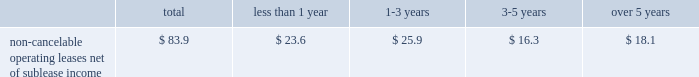Building .
The construction of the building was completed in december 2003 .
Due to lower than expected financing and construction costs , the final lease balance was lowered to $ 103.0 million .
As part of the agreement , we entered into a five-year lease that began upon the completion of the building .
At the end of the lease term , we can purchase the building for the lease balance , remarket or relinquish the building .
If we choose to remarket or are required to do so upon relinquishing the building , we are bound to arrange the sale of the building to an unrelated party and will be required to pay the lessor any shortfall between the net remarketing proceeds and the lease balance , up to the maximum recourse amount of $ 90.8 million ( 201cresidual value guarantee 201d ) .
See note 14 in our notes to consolidated financial statements for further information .
In august 1999 , we entered into a five-year lease agreement for our other two office buildings that currently serve as our corporate headquarters in san jose , california .
Under the agreement , we have the option to purchase the buildings at any time during the lease term for the lease balance , which is approximately $ 142.5 million .
We are in the process of evaluating alternative financing methods at expiration of the lease in fiscal 2004 and believe that several suitable financing options will be available to us .
At the end of the lease term , we can purchase the buildings for the lease balance , remarket or relinquish the buildings .
If we choose to remarket or are required to do so upon relinquishing the buildings , we are bound to arrange the sale of the buildings to an unrelated party and will be required to pay the lessor any shortfall between the net remarketing proceeds and the lease balance , up to the maximum recourse amount of $ 132.6 million ( 201cresidual value guarantee 201d ) .
For further information , see note 14 in our notes to consolidated financial statements .
The two lease agreements discussed above are subject to standard financial covenants .
The agreements limit the amount of indebtedness we can incur .
A leverage covenant requires us to keep our debt to ebitda ratio less than 2.5:1.0 .
As of november 28 , 2003 , our debt to ebitda ratio was 0.53:1.0 , well within the limit .
We also have a liquidity covenant which requires us to maintain a quick ratio equal to or greater than 1.0 .
As of november 28 , 2003 , our quick ratio was 2.2 , well above the minimum .
We expect to remain within compliance in the next 12 months .
We are comfortable with these limitations and believe they will not impact our cash or credit in the coming year or restrict our ability to execute our business plan .
The table summarizes our contractual commitments as of november 28 , 2003 : less than over total 1 year 1 2013 3 years 3-5 years 5 years non-cancelable operating leases , net of sublease income ................ .
$ 83.9 $ 23.6 $ 25.9 $ 16.3 $ 18.1 indemnifications in the normal course of business , we provide indemnifications of varying scope to customers against claims of intellectual property infringement made by third parties arising from the use of our products .
Historically , costs related to these indemnification provisions have not been significant and we are unable to estimate the maximum potential impact of these indemnification provisions on our future results of operations .
We have commitments to make certain milestone and/or retention payments typically entered into in conjunction with various acquisitions , for which we have made accruals in our consolidated financial statements .
In connection with our purchases of technology assets during fiscal 2003 , we entered into employee retention agreements totaling $ 2.2 million .
We are required to make payments upon satisfaction of certain conditions in the agreements .
As permitted under delaware law , we have agreements whereby we indemnify our officers and directors for certain events or occurrences while the officer or director is , or was serving , at our request in such capacity .
The indemnification period covers all pertinent events and occurrences during the officer 2019s or director 2019s lifetime .
The maximum potential amount of future payments we could be required to make under these indemnification agreements is unlimited ; however , we have director and officer insurance coverage that limits our exposure and enables us to recover a portion of any future amounts paid .
We believe the estimated fair value of these indemnification agreements in excess of applicable insurance coverage is minimal. .
Building .
The construction of the building was completed in december 2003 .
Due to lower than expected financing and construction costs , the final lease balance was lowered to $ 103.0 million .
As part of the agreement , we entered into a five-year lease that began upon the completion of the building .
At the end of the lease term , we can purchase the building for the lease balance , remarket or relinquish the building .
If we choose to remarket or are required to do so upon relinquishing the building , we are bound to arrange the sale of the building to an unrelated party and will be required to pay the lessor any shortfall between the net remarketing proceeds and the lease balance , up to the maximum recourse amount of $ 90.8 million ( 201cresidual value guarantee 201d ) .
See note 14 in our notes to consolidated financial statements for further information .
In august 1999 , we entered into a five-year lease agreement for our other two office buildings that currently serve as our corporate headquarters in san jose , california .
Under the agreement , we have the option to purchase the buildings at any time during the lease term for the lease balance , which is approximately $ 142.5 million .
We are in the process of evaluating alternative financing methods at expiration of the lease in fiscal 2004 and believe that several suitable financing options will be available to us .
At the end of the lease term , we can purchase the buildings for the lease balance , remarket or relinquish the buildings .
If we choose to remarket or are required to do so upon relinquishing the buildings , we are bound to arrange the sale of the buildings to an unrelated party and will be required to pay the lessor any shortfall between the net remarketing proceeds and the lease balance , up to the maximum recourse amount of $ 132.6 million ( 201cresidual value guarantee 201d ) .
For further information , see note 14 in our notes to consolidated financial statements .
The two lease agreements discussed above are subject to standard financial covenants .
The agreements limit the amount of indebtedness we can incur .
A leverage covenant requires us to keep our debt to ebitda ratio less than 2.5:1.0 .
As of november 28 , 2003 , our debt to ebitda ratio was 0.53:1.0 , well within the limit .
We also have a liquidity covenant which requires us to maintain a quick ratio equal to or greater than 1.0 .
As of november 28 , 2003 , our quick ratio was 2.2 , well above the minimum .
We expect to remain within compliance in the next 12 months .
We are comfortable with these limitations and believe they will not impact our cash or credit in the coming year or restrict our ability to execute our business plan .
The following table summarizes our contractual commitments as of november 28 , 2003 : less than over total 1 year 1 2013 3 years 3-5 years 5 years non-cancelable operating leases , net of sublease income ................ .
$ 83.9 $ 23.6 $ 25.9 $ 16.3 $ 18.1 indemnifications in the normal course of business , we provide indemnifications of varying scope to customers against claims of intellectual property infringement made by third parties arising from the use of our products .
Historically , costs related to these indemnification provisions have not been significant and we are unable to estimate the maximum potential impact of these indemnification provisions on our future results of operations .
We have commitments to make certain milestone and/or retention payments typically entered into in conjunction with various acquisitions , for which we have made accruals in our consolidated financial statements .
In connection with our purchases of technology assets during fiscal 2003 , we entered into employee retention agreements totaling $ 2.2 million .
We are required to make payments upon satisfaction of certain conditions in the agreements .
As permitted under delaware law , we have agreements whereby we indemnify our officers and directors for certain events or occurrences while the officer or director is , or was serving , at our request in such capacity .
The indemnification period covers all pertinent events and occurrences during the officer 2019s or director 2019s lifetime .
The maximum potential amount of future payments we could be required to make under these indemnification agreements is unlimited ; however , we have director and officer insurance coverage that limits our exposure and enables us to recover a portion of any future amounts paid .
We believe the estimated fair value of these indemnification agreements in excess of applicable insurance coverage is minimal. .
What percent of non-cancelable operating leases net of sublease income are due in less than one year? 
Computations: (23.6 / 83.9)
Answer: 0.28129. 